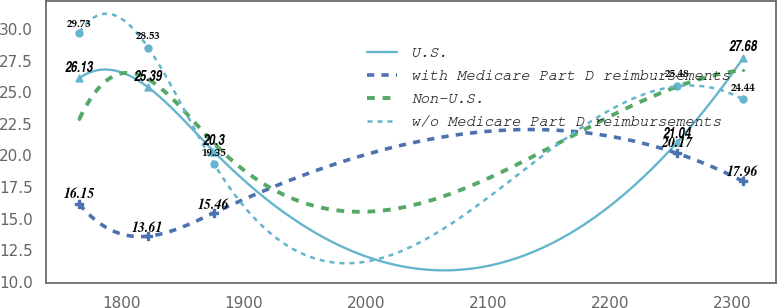<chart> <loc_0><loc_0><loc_500><loc_500><line_chart><ecel><fcel>U.S.<fcel>with Medicare Part D reimbursements<fcel>Non-U.S.<fcel>w/o Medicare Part D reimbursements<nl><fcel>1765.58<fcel>26.13<fcel>16.15<fcel>22.88<fcel>29.73<nl><fcel>1822<fcel>25.39<fcel>13.61<fcel>26.03<fcel>28.53<nl><fcel>1875.83<fcel>20.3<fcel>15.46<fcel>20.96<fcel>19.35<nl><fcel>2254.88<fcel>21.04<fcel>20.17<fcel>25.45<fcel>25.48<nl><fcel>2308.71<fcel>27.68<fcel>17.96<fcel>26.77<fcel>24.44<nl></chart> 